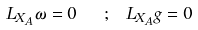<formula> <loc_0><loc_0><loc_500><loc_500>L _ { X _ { A } } \omega = 0 \ \ ; \ L _ { X _ { A } } g = 0</formula> 